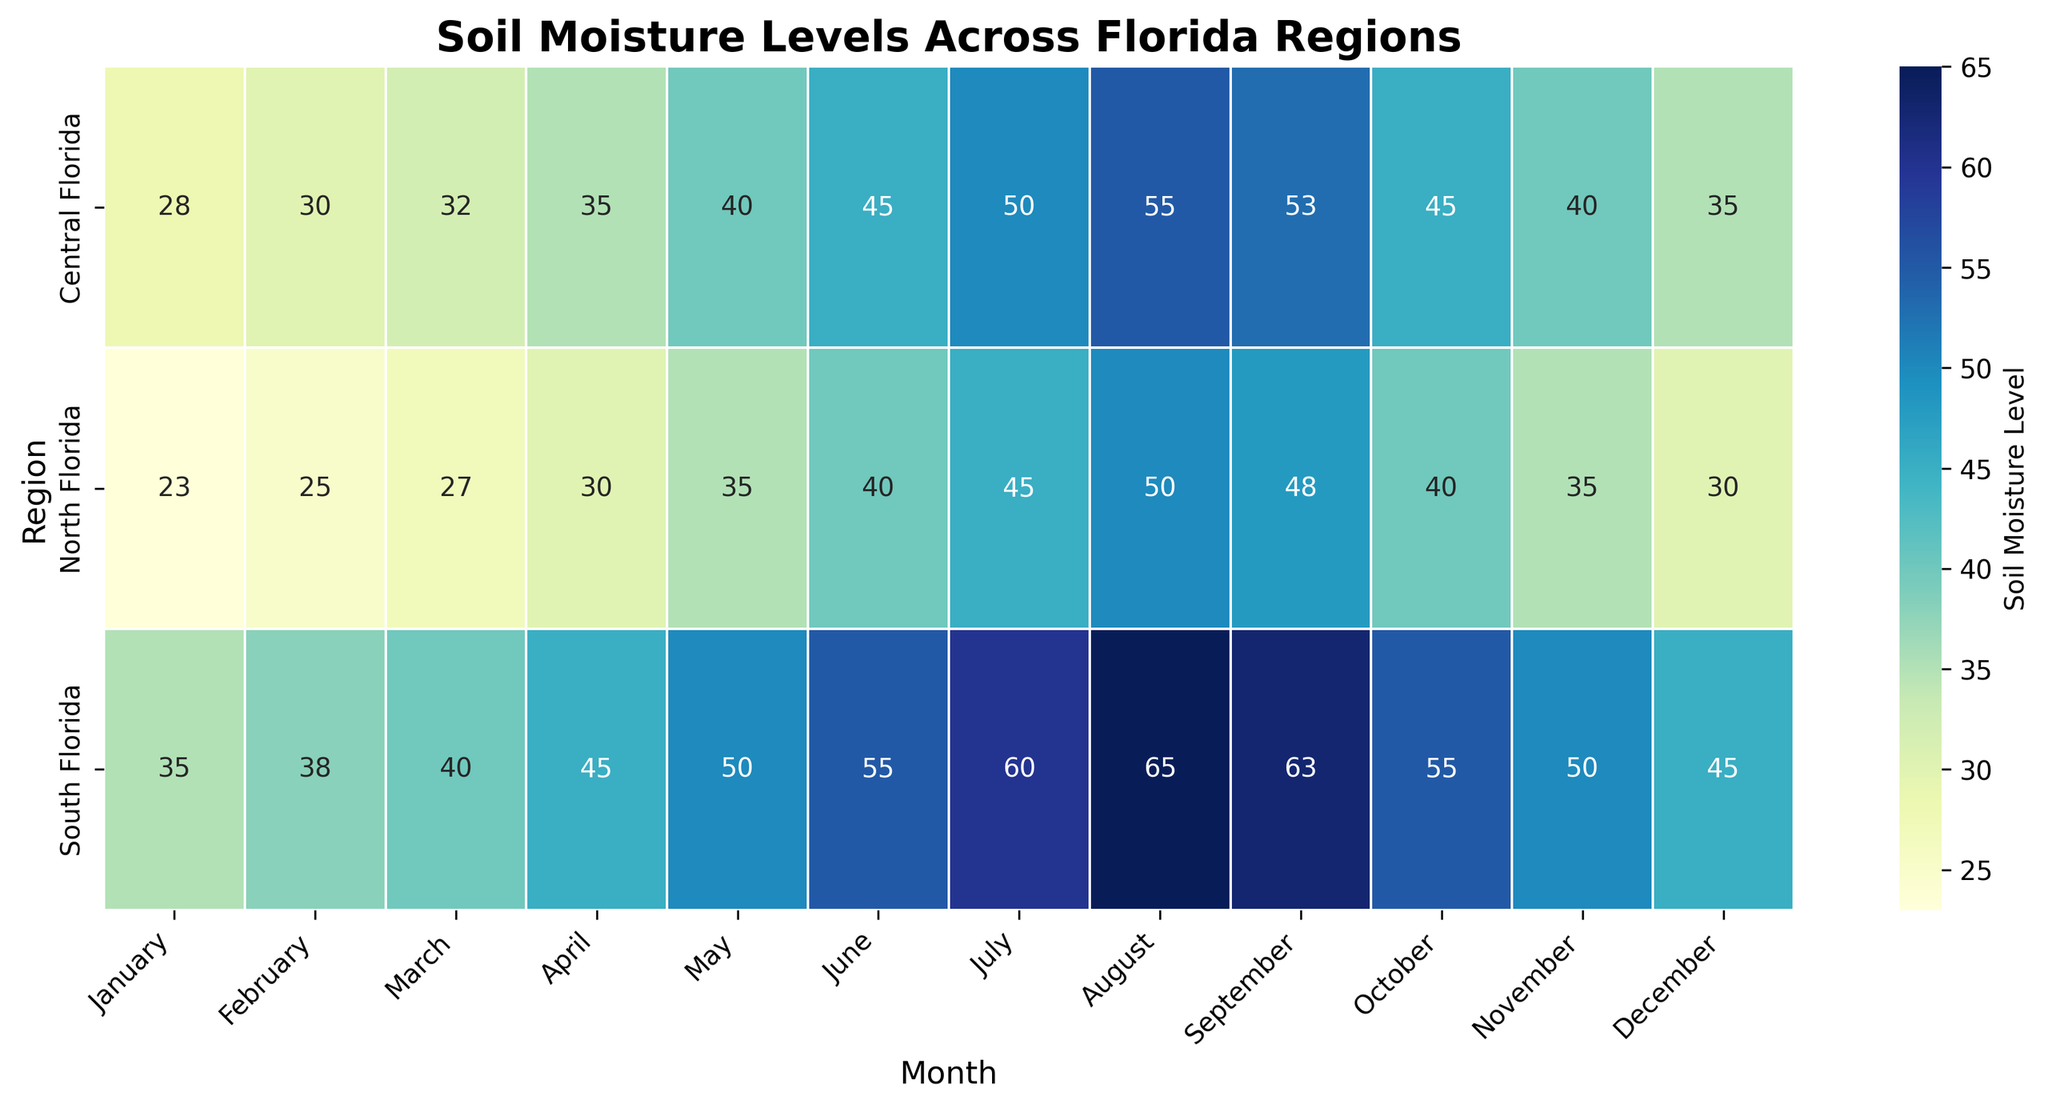What's the title of the plot? The title of the plot is located at the top and is in bold font.
Answer: Soil Moisture Levels Across Florida Regions Which region has the highest soil moisture level in July? By looking at the row labeled 'July' across all regions, find the highest value. 'South Florida' has the highest soil moisture level of 60.
Answer: South Florida How does the soil moisture level in North Florida change from January to December? Locate the row for 'North Florida,' and observe the changes in soil moisture from January to December. It starts at 23 in January and increases to 50 in August, then decreases back to 30 in December.
Answer: Starts at 23, increases to 50 in August, then decreases to 30 What is the average soil moisture level for Central Florida throughout the year? Sum the soil moisture levels for the 'Central Florida' row and divide by 12 (the number of months). Sum is 493, and the average is 493/12.
Answer: 41.08 Which month has the highest overall soil moisture level across all regions? Check each column for the highest value. The 'August' column has the highest overall value at 65 in South Florida.
Answer: August What is the difference in soil moisture levels between Central and South Florida in June? Identify the values in the 'June' column for Central (45) and South (55) Florida, then subtract. 55 - 45 = 10.
Answer: 10 Compare the soil moisture levels in February between North and Central Florida. Which region has higher levels? Look at the 'February' column, with values for North (25) and Central (30). Central Florida has higher soil moisture level.
Answer: Central Florida Is there a notable trend in soil moisture levels from January to December in South Florida? For the 'South Florida' row, observe the moisture levels. They rise steadily from 35 in January to a peak of 65 in August, then decrease to 45 by December.
Answer: Increases, peaks in August, then decreases What's the median soil moisture level for North Florida? Organize North Florida's values: 23, 25, 27, 30, 35, 40, 40, 45, 48, 30, 35, 40. Since there are 12 values, the median is the average of the 6th and 7th values. (35 + 40)/2 = 37.5.
Answer: 37.5 